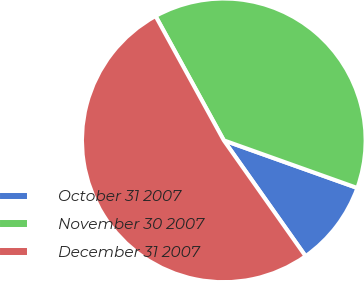Convert chart. <chart><loc_0><loc_0><loc_500><loc_500><pie_chart><fcel>October 31 2007<fcel>November 30 2007<fcel>December 31 2007<nl><fcel>9.76%<fcel>38.44%<fcel>51.79%<nl></chart> 